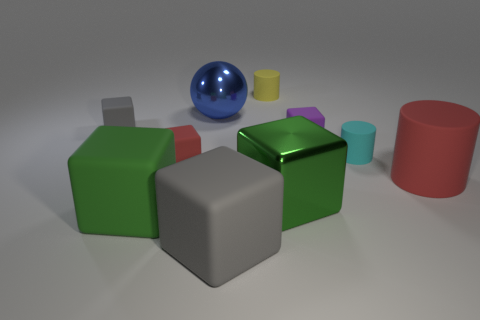Could you infer the texture of the objects and describe any two in detail? Certainly, the objects in the image display a variety of textures. The red matte cubes, for example, have a diffuse reflection which suggests a more porous or rough surface that scatters the light. On the other hand, the cyan cylinder on the far right appears to have a smoother, perhaps slightly rubbery texture as indicated by its soft, matte finish and the subtle light absorption.  How is the lighting set up in this scene? The lighting setup in this scene seems to consist of a diffuse overhead light source which casts soft shadows beneath the objects. The lack of harsh shadows or strong directional light indicates that the lighting is meant to minimize glare and showcase the objects without any particular bias towards angle or intensity. This is a common setup for product visualization or instructional materials, where clarity is paramount. 